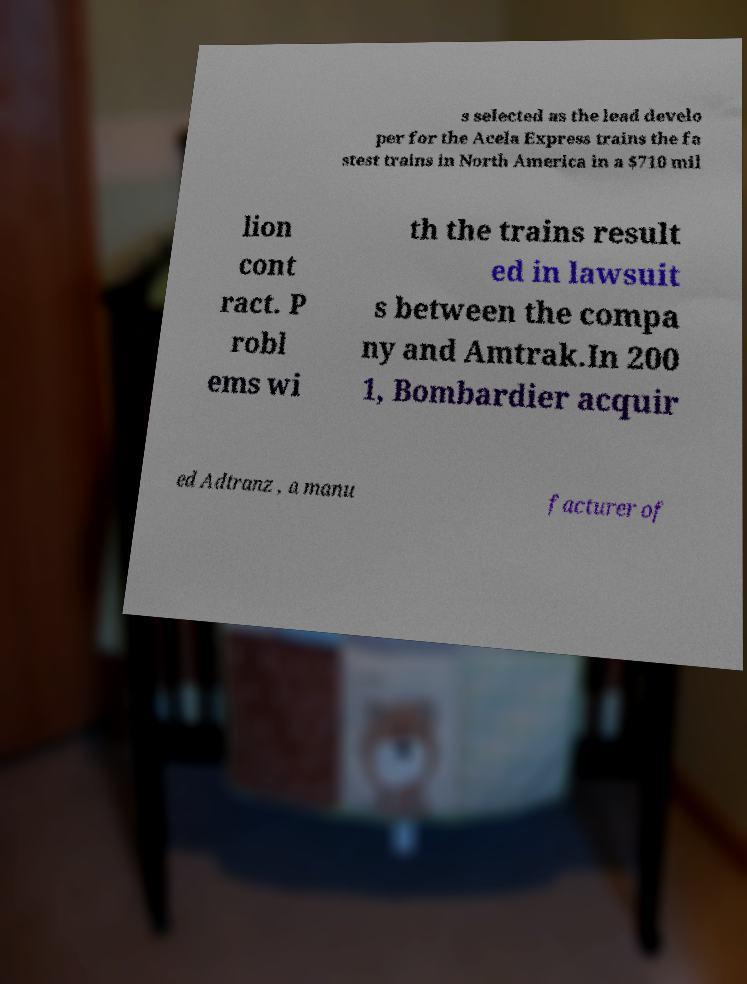Please identify and transcribe the text found in this image. s selected as the lead develo per for the Acela Express trains the fa stest trains in North America in a $710 mil lion cont ract. P robl ems wi th the trains result ed in lawsuit s between the compa ny and Amtrak.In 200 1, Bombardier acquir ed Adtranz , a manu facturer of 